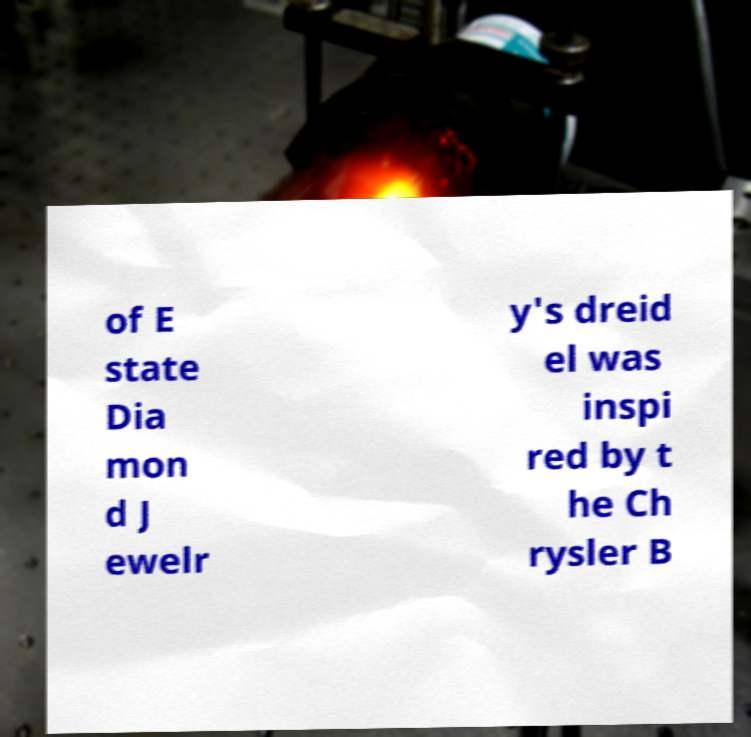I need the written content from this picture converted into text. Can you do that? of E state Dia mon d J ewelr y's dreid el was inspi red by t he Ch rysler B 